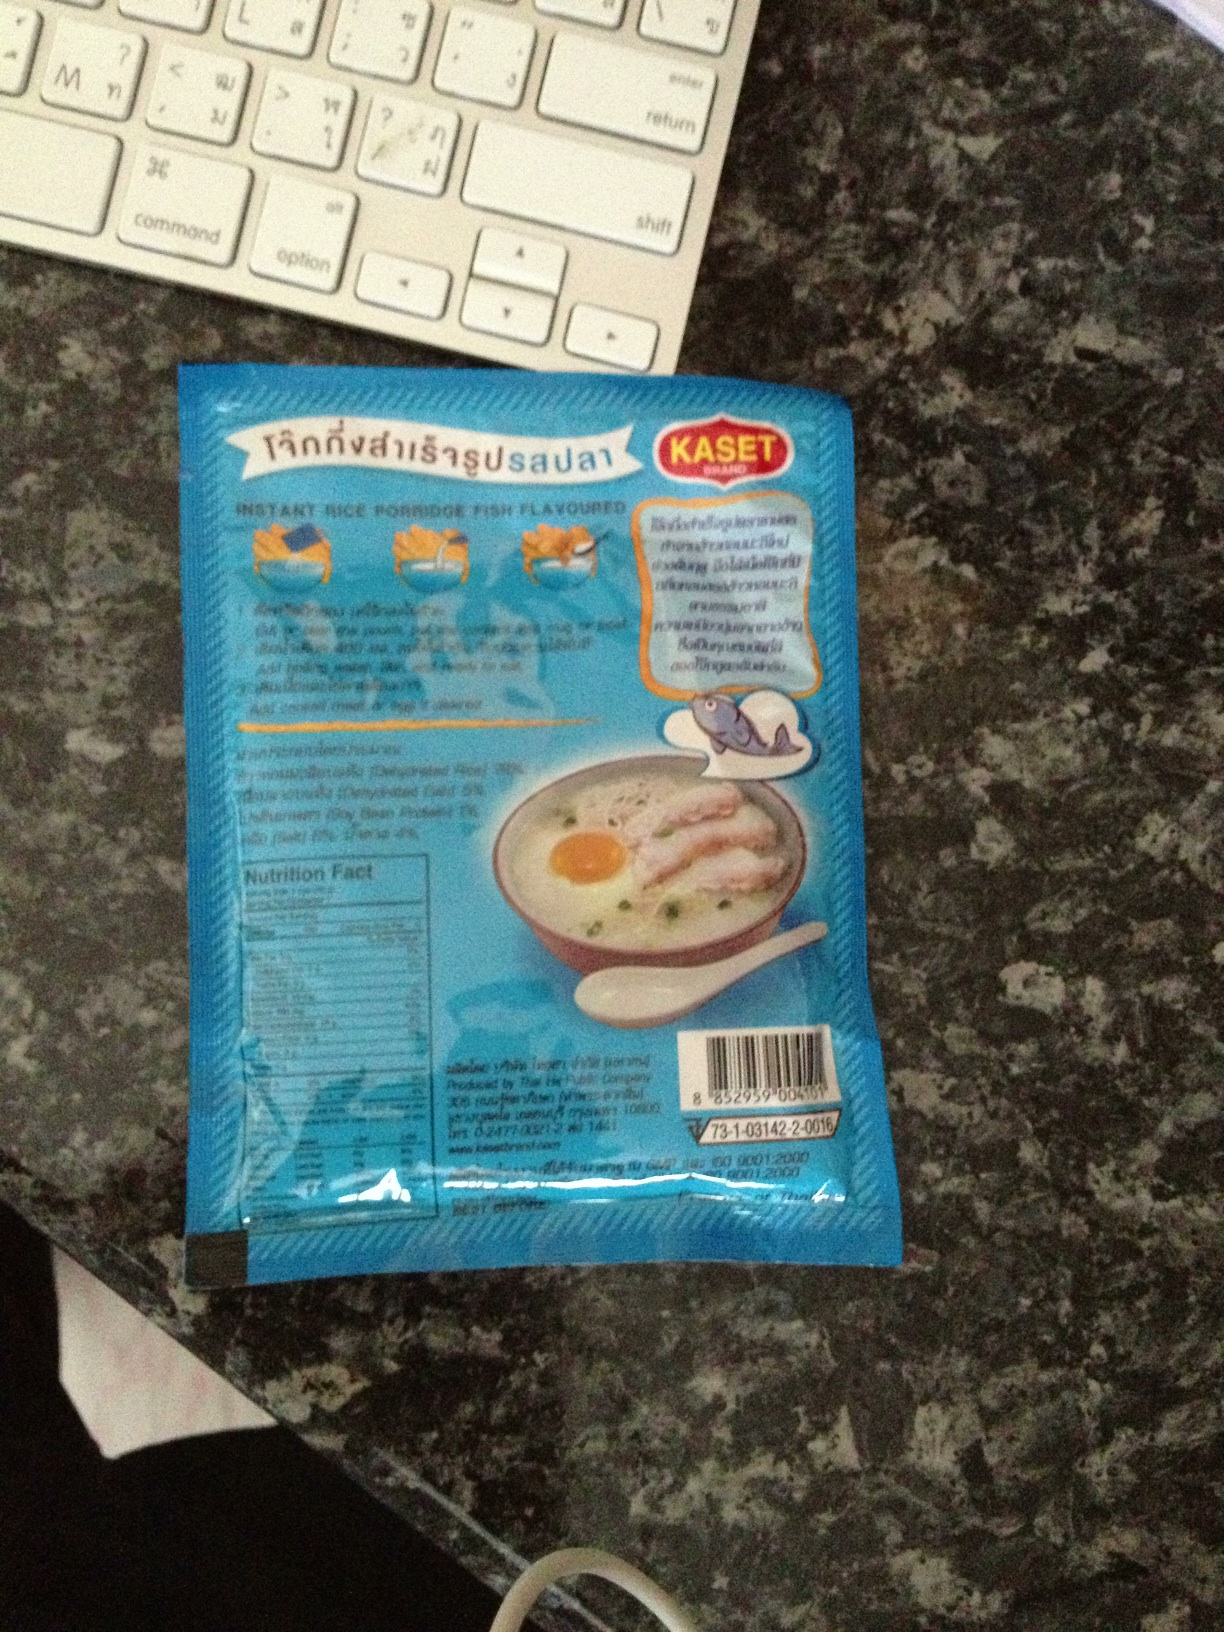What are the nutritional facts mentioned on this package? Unfortunately, the details in the nutrition facts label on the packaging are too small to discern in this image. Typically, such labels would include information about the calorie count, macronutrients like fats, carbohydrates, and proteins, as well as other ingredients and allergens. 